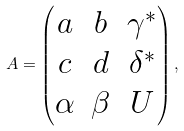<formula> <loc_0><loc_0><loc_500><loc_500>A = \begin{pmatrix} a & b & \gamma ^ { \ast } \\ c & d & \delta ^ { \ast } \\ \alpha & \beta & U \end{pmatrix} ,</formula> 